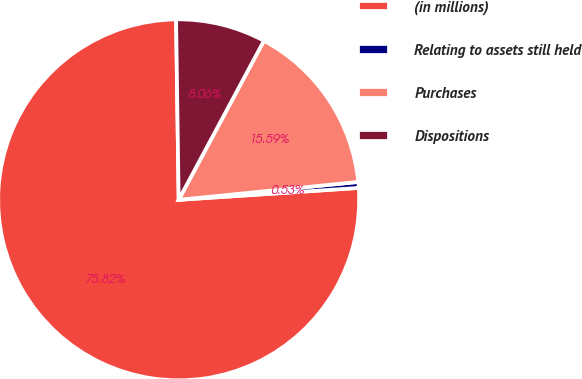Convert chart to OTSL. <chart><loc_0><loc_0><loc_500><loc_500><pie_chart><fcel>(in millions)<fcel>Relating to assets still held<fcel>Purchases<fcel>Dispositions<nl><fcel>75.83%<fcel>0.53%<fcel>15.59%<fcel>8.06%<nl></chart> 